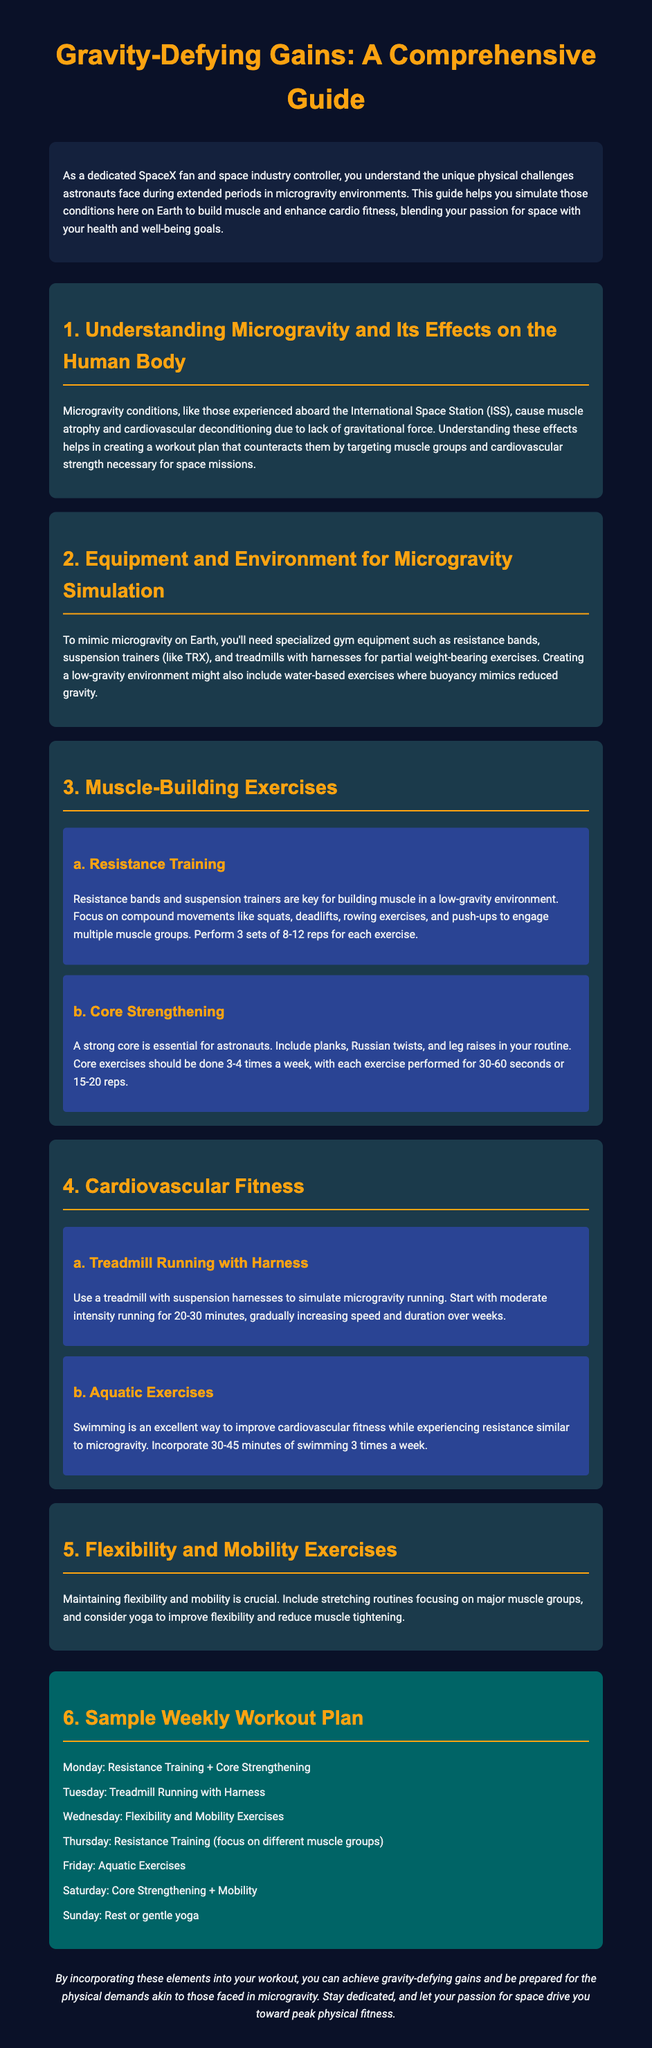what is the title of the document? The title of the document is mentioned at the top of the rendered page.
Answer: Gravity-Defying Gains: A Comprehensive Guide how many times a week should core exercises be performed? The document specifies how often core exercises should be included in the workout routine.
Answer: 3-4 times a week what equipment is recommended for simulating microgravity? The document lists the necessary equipment for mimicking microgravity conditions.
Answer: Resistance bands, suspension trainers, treadmills with harnesses what type of exercises should be included for cardiovascular fitness? The document describes specific exercises to enhance cardiovascular fitness in microgravity conditions.
Answer: Treadmill Running with Harness; Aquatic Exercises how many sets and reps are recommended for resistance training exercises? The document specifies the recommended sets and repetitions for resistance training.
Answer: 3 sets of 8-12 reps which day is designated for flexibility and mobility exercises? The document outlines a workout plan, specifying activities assigned to each day.
Answer: Wednesday what is the focus of Thursday's workout? The document details the focus of exercises for each day of the week.
Answer: Resistance Training (focus on different muscle groups) 